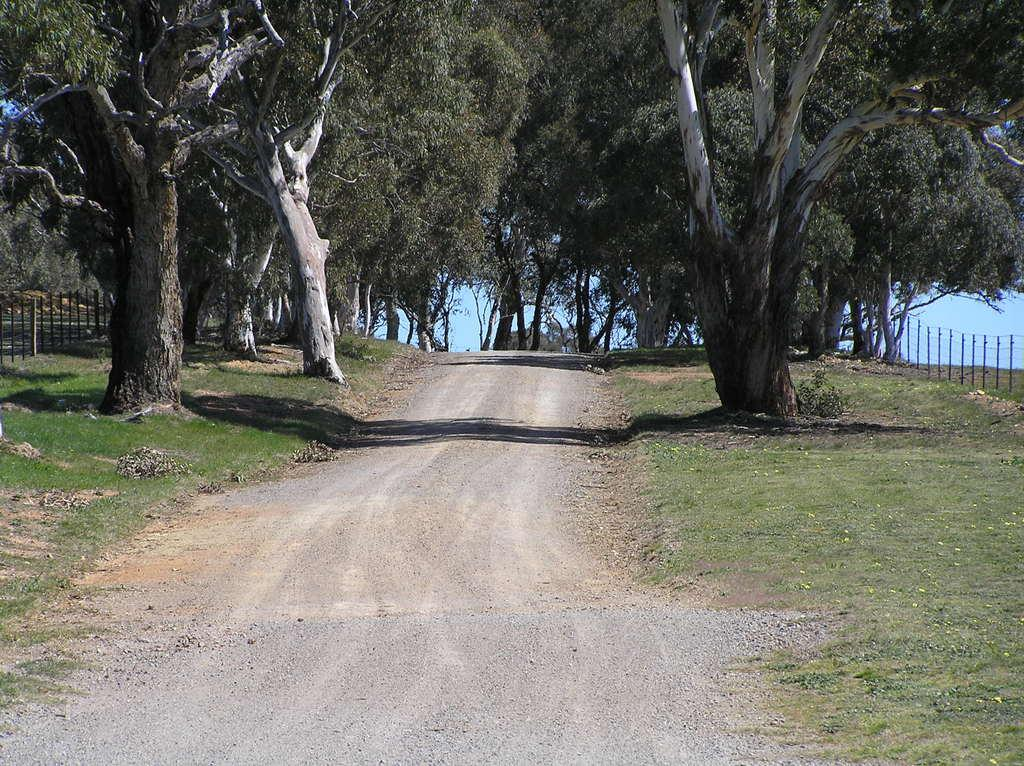What is located in the center of the image? There is a walkway in the center of the image. What can be seen in the background of the image? There are trees in the background of the image. What type of barrier is visible in the image? There is a fence visible in the image. What is the nature of the water in the image? The water is present in the image, but its specific nature is not mentioned in the facts. What type of ornament is hanging from the cow in the image? There is no cow or ornament present in the image. 